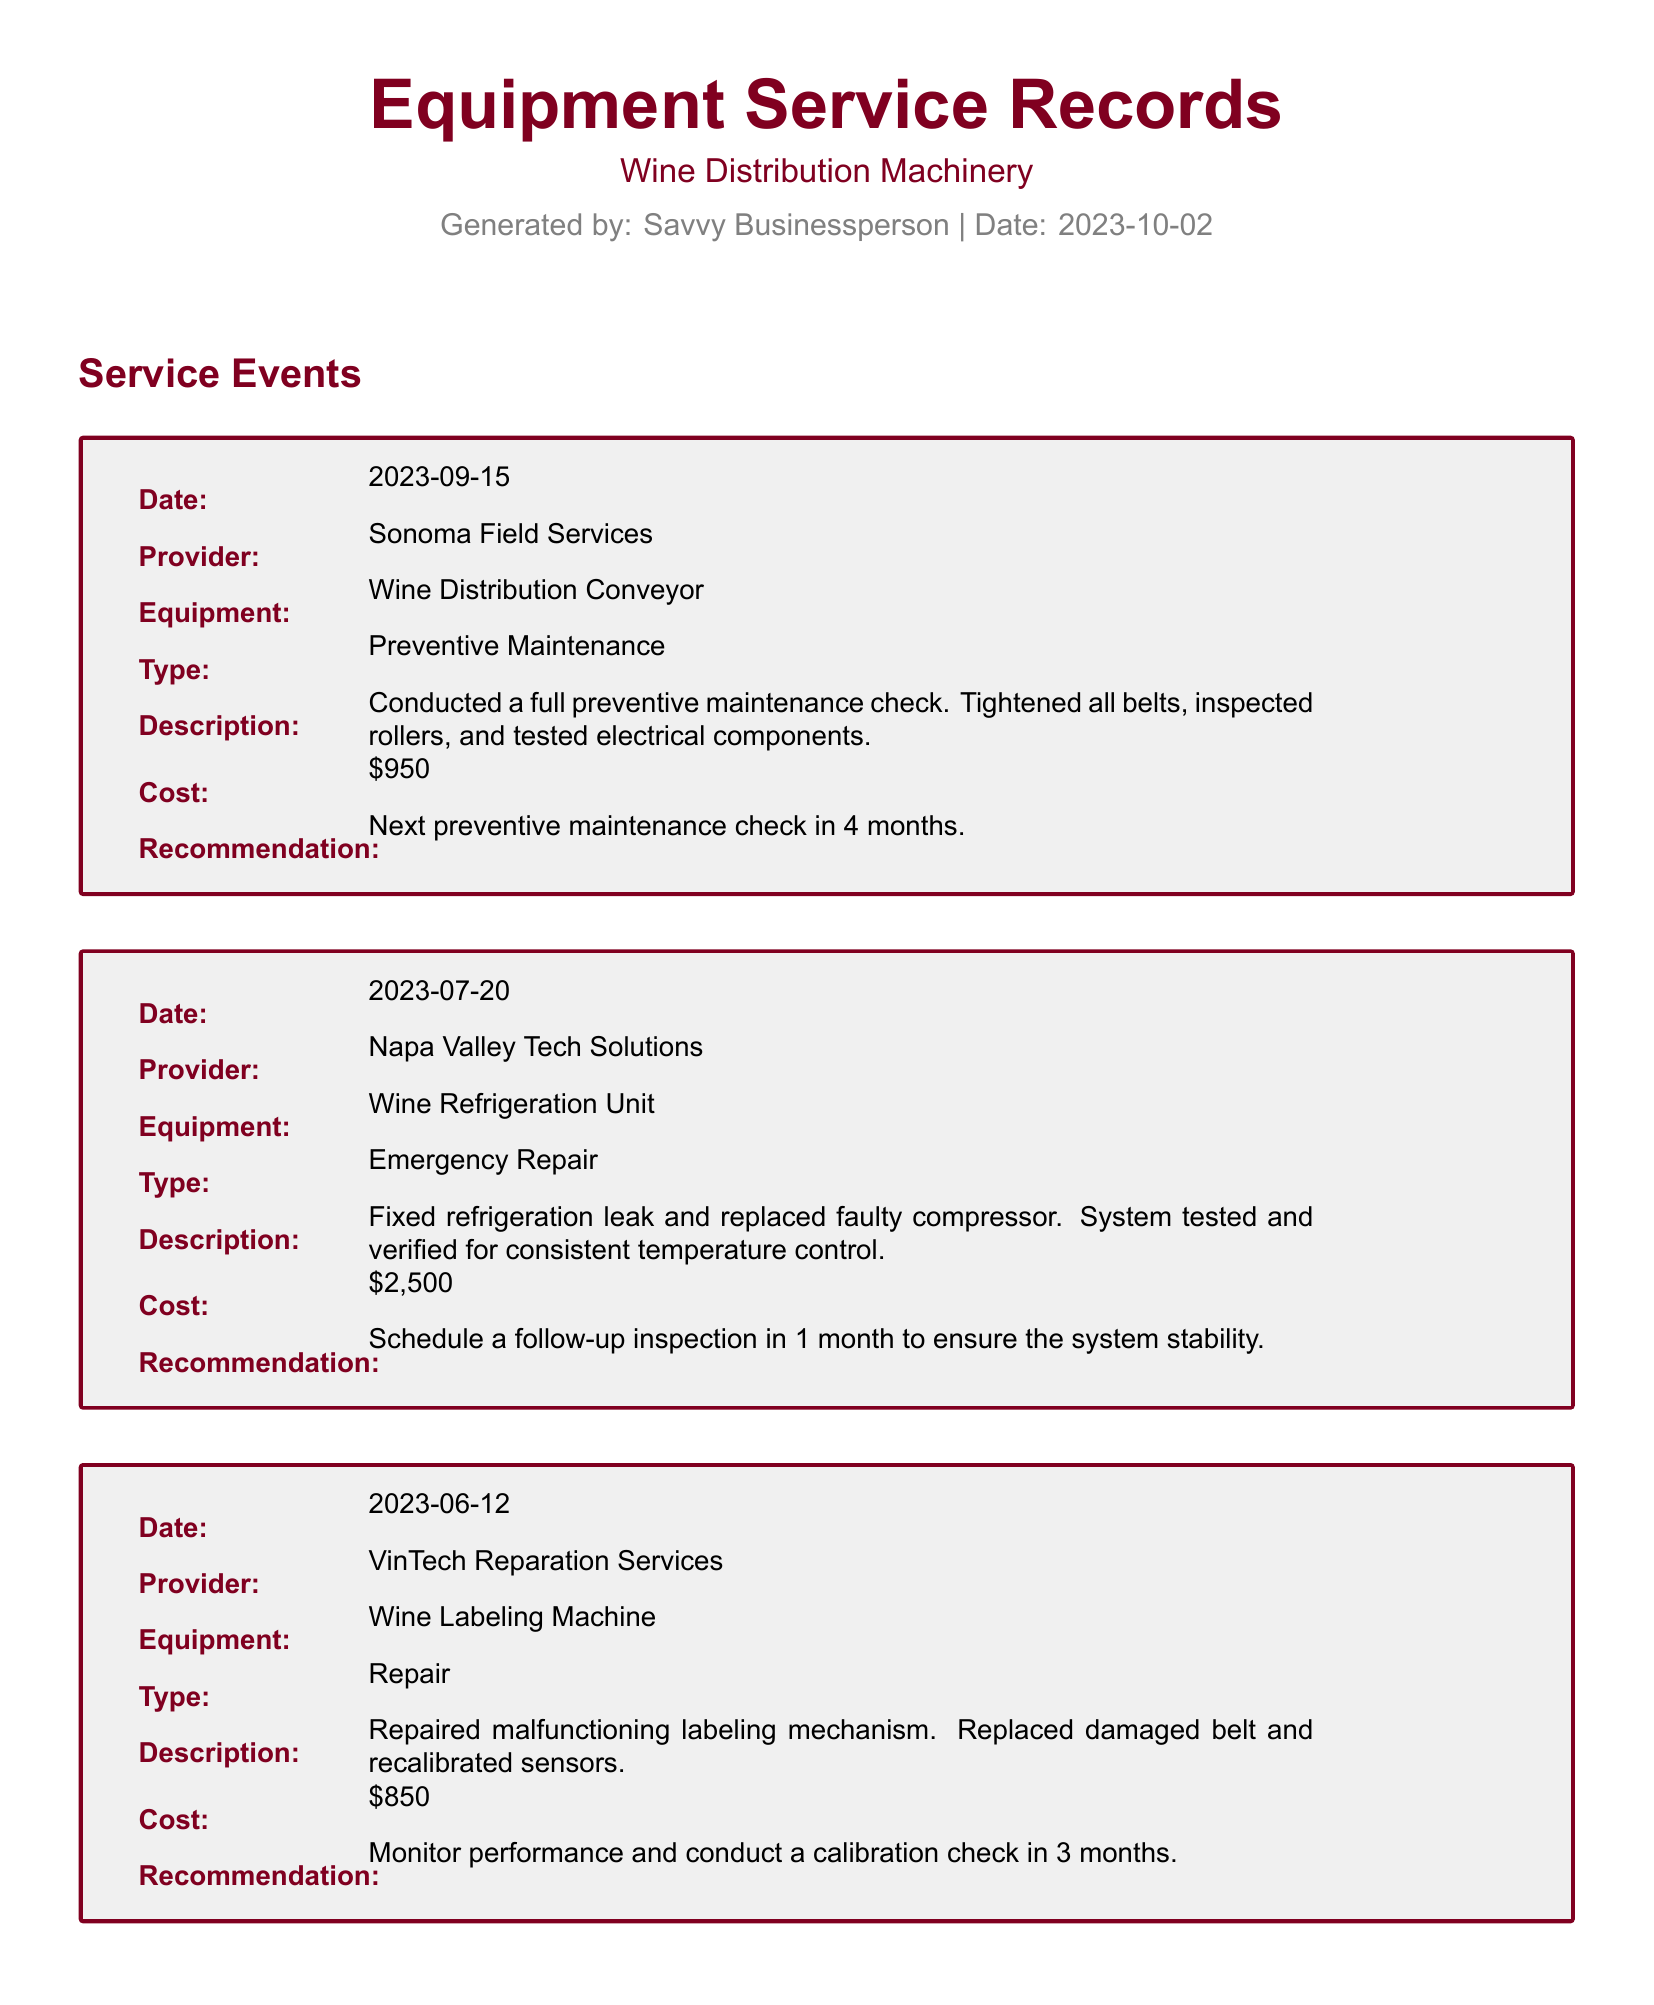What is the total maintenance cost? The total maintenance cost is provided in the summary section of the document.
Answer: $5,500 Who conducted the preventive maintenance on September 15, 2023? The service provider for the preventive maintenance on this date is listed in the service event section.
Answer: Sonoma Field Services What type of service was performed on July 20, 2023? The type of service is identified in the service event section for that date.
Answer: Emergency Repair What is the recommendation after the repair of the wine labeling machine? The recommendation for monitoring performance is included in the description of the service event.
Answer: Monitor performance and conduct a calibration check in 3 months When is the follow-up inspection scheduled for the wine refrigeration unit? The follow-up inspection date is mentioned in the recommendation for the emergency repair listed in the document.
Answer: 2023-08-20 How many months until the next preventive maintenance is scheduled for the wine distribution conveyor? The recommendation specifies the duration until the next preventive maintenance check for this equipment.
Answer: 4 months What is the date of the most recent service event? The most recent service date is summarized at the end of the document.
Answer: 2023-09-15 Which equipment had a refrigeration leak fixed? The equipment with the issue is detailed in the service event section describing the emergency repair.
Answer: Wine Refrigeration Unit 